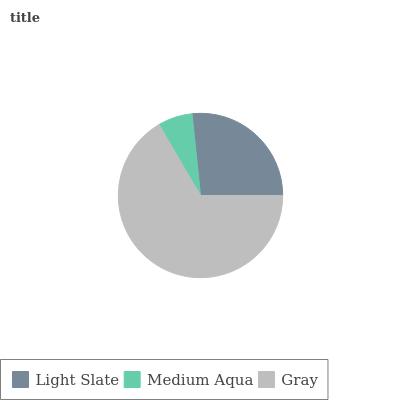Is Medium Aqua the minimum?
Answer yes or no. Yes. Is Gray the maximum?
Answer yes or no. Yes. Is Gray the minimum?
Answer yes or no. No. Is Medium Aqua the maximum?
Answer yes or no. No. Is Gray greater than Medium Aqua?
Answer yes or no. Yes. Is Medium Aqua less than Gray?
Answer yes or no. Yes. Is Medium Aqua greater than Gray?
Answer yes or no. No. Is Gray less than Medium Aqua?
Answer yes or no. No. Is Light Slate the high median?
Answer yes or no. Yes. Is Light Slate the low median?
Answer yes or no. Yes. Is Medium Aqua the high median?
Answer yes or no. No. Is Gray the low median?
Answer yes or no. No. 